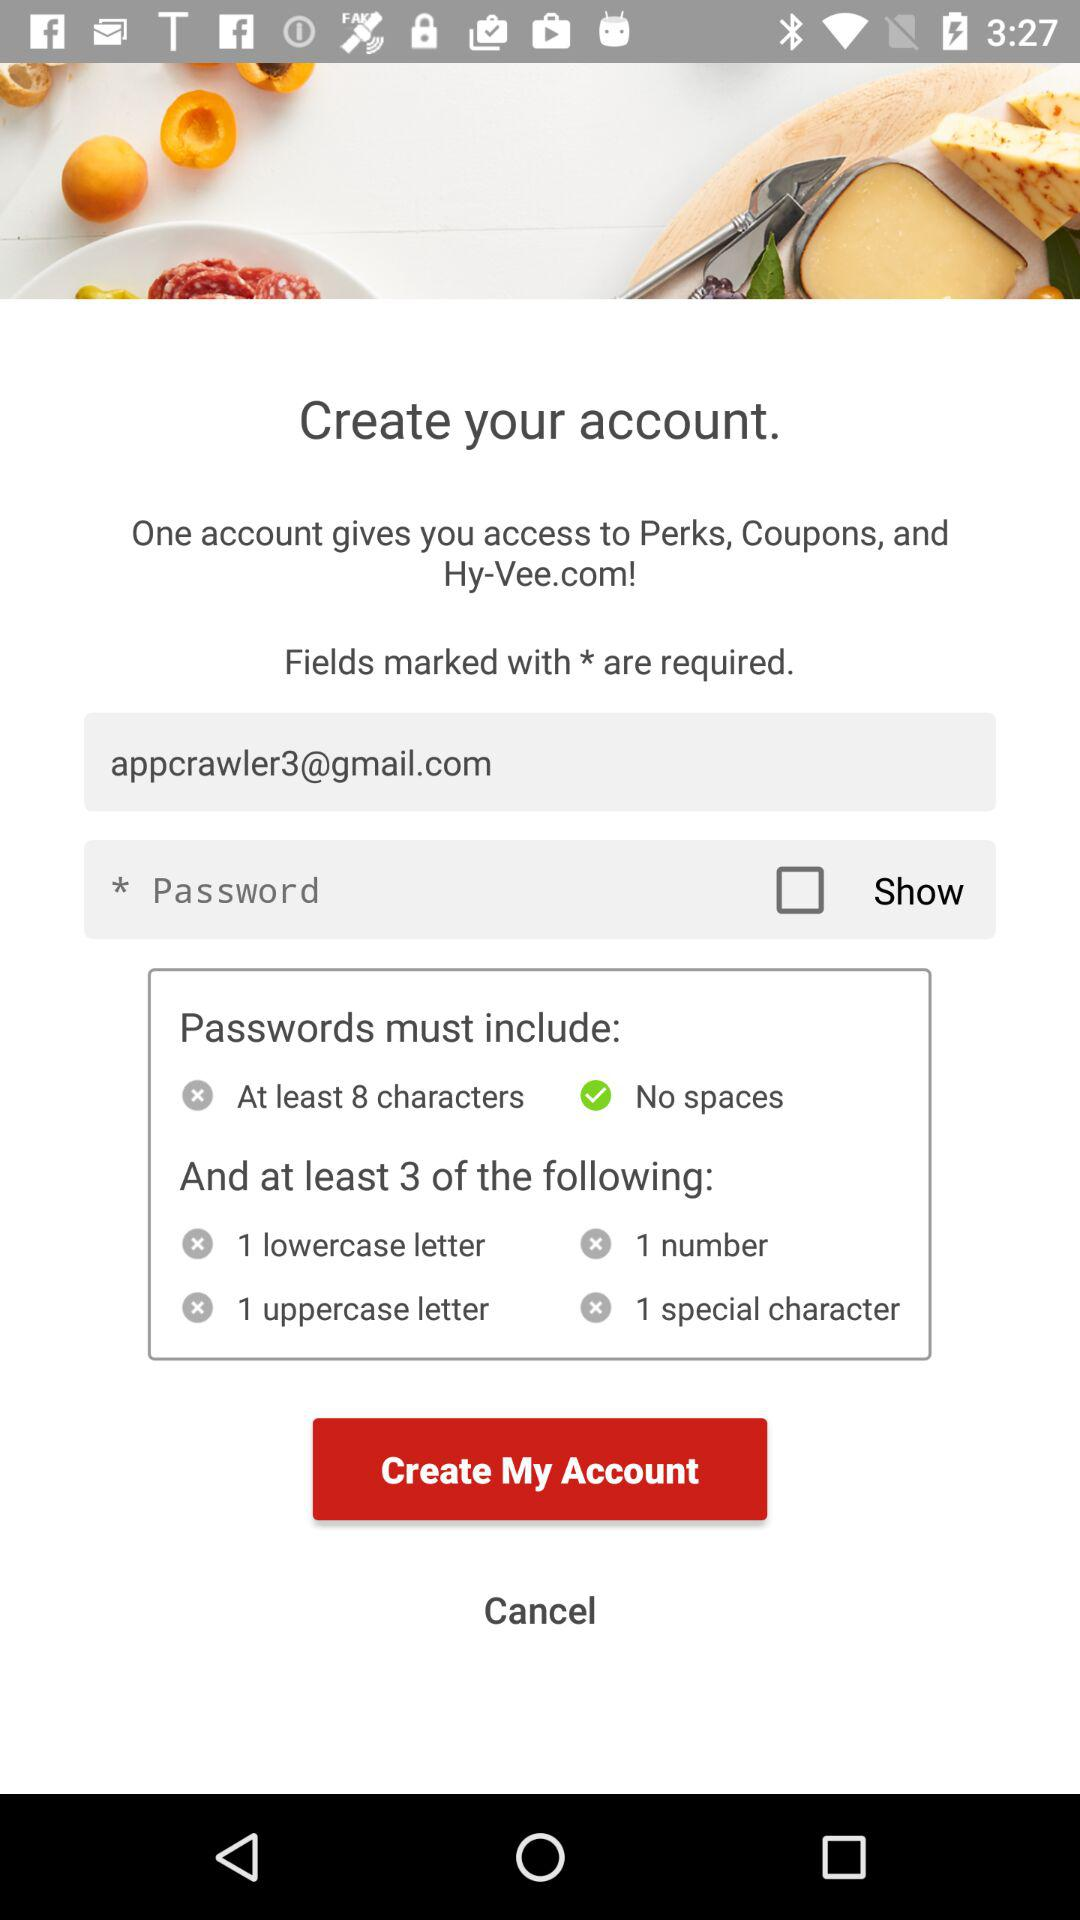What should the password include? The password should include at least 8 characters with no spaces and at least 3 of the following: "1 lowercase letter", "1 number", "1 uppercase letter" and "1 special character". 